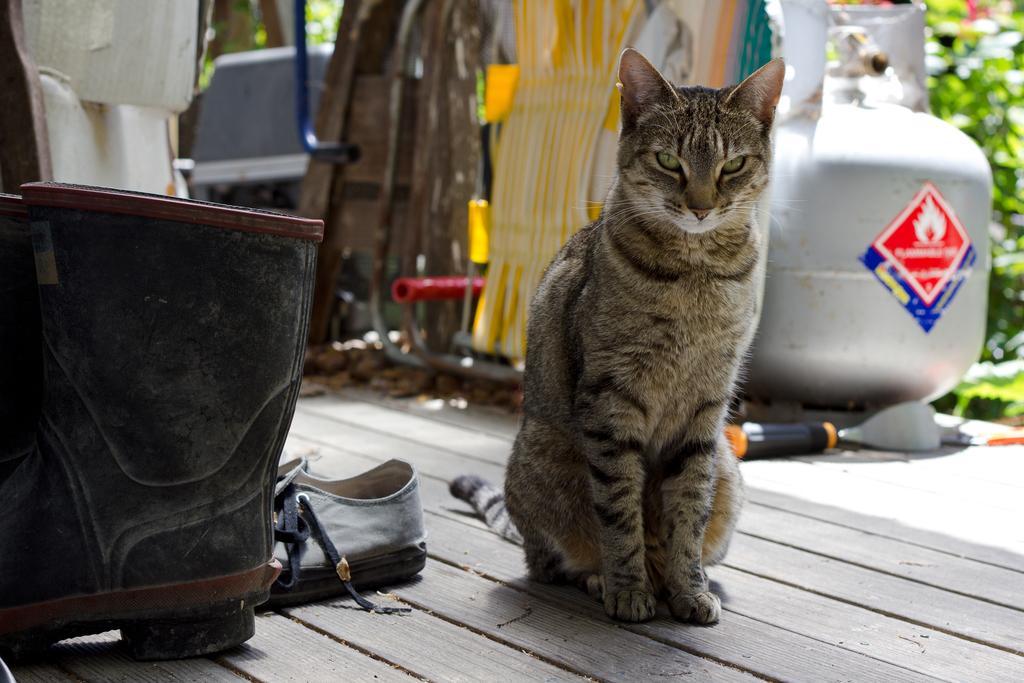In one or two sentences, can you explain what this image depicts? In this picture there is a cat sitting on the wooden platform and we can see footwear. In the background of the image it is blurry and we can see objects and green leaves. 